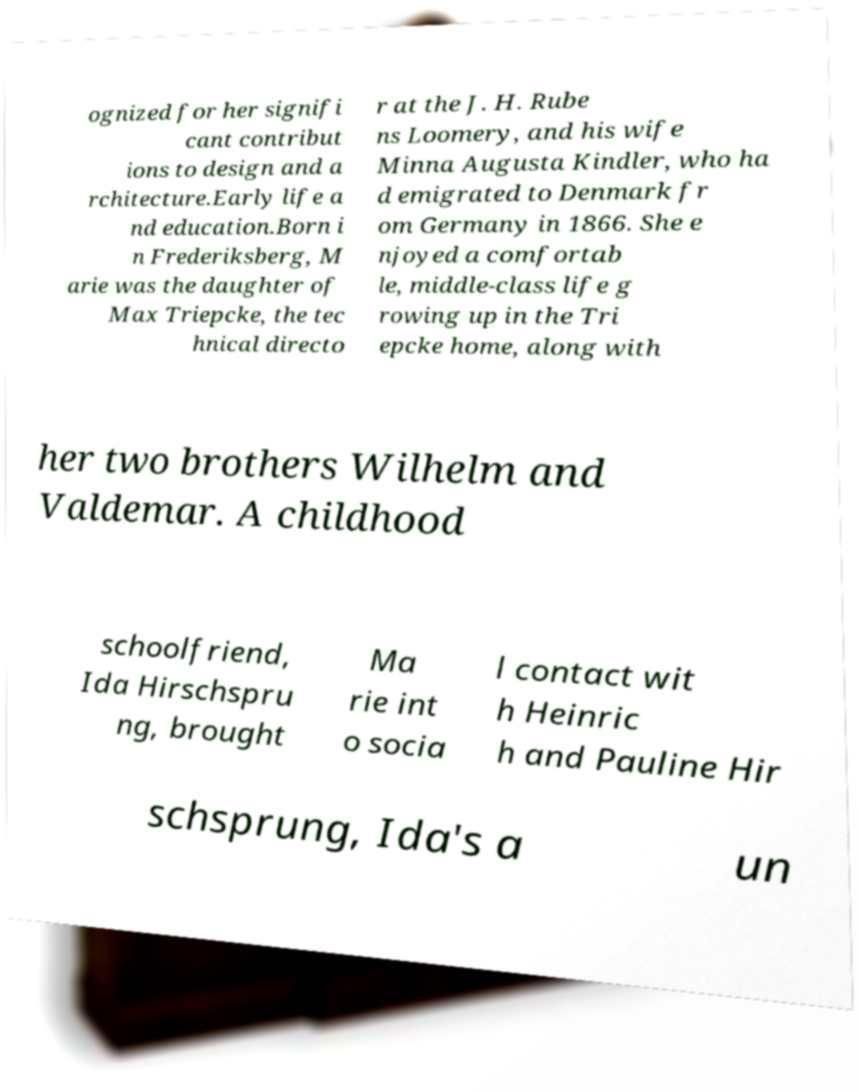Please read and relay the text visible in this image. What does it say? ognized for her signifi cant contribut ions to design and a rchitecture.Early life a nd education.Born i n Frederiksberg, M arie was the daughter of Max Triepcke, the tec hnical directo r at the J. H. Rube ns Loomery, and his wife Minna Augusta Kindler, who ha d emigrated to Denmark fr om Germany in 1866. She e njoyed a comfortab le, middle-class life g rowing up in the Tri epcke home, along with her two brothers Wilhelm and Valdemar. A childhood schoolfriend, Ida Hirschspru ng, brought Ma rie int o socia l contact wit h Heinric h and Pauline Hir schsprung, Ida's a un 